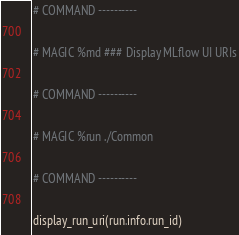Convert code to text. <code><loc_0><loc_0><loc_500><loc_500><_Python_>
# COMMAND ----------

# MAGIC %md ### Display MLflow UI URIs

# COMMAND ----------

# MAGIC %run ./Common

# COMMAND ----------

display_run_uri(run.info.run_id)</code> 